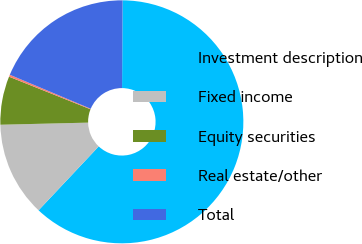Convert chart. <chart><loc_0><loc_0><loc_500><loc_500><pie_chart><fcel>Investment description<fcel>Fixed income<fcel>Equity securities<fcel>Real estate/other<fcel>Total<nl><fcel>61.92%<fcel>12.6%<fcel>6.44%<fcel>0.27%<fcel>18.77%<nl></chart> 